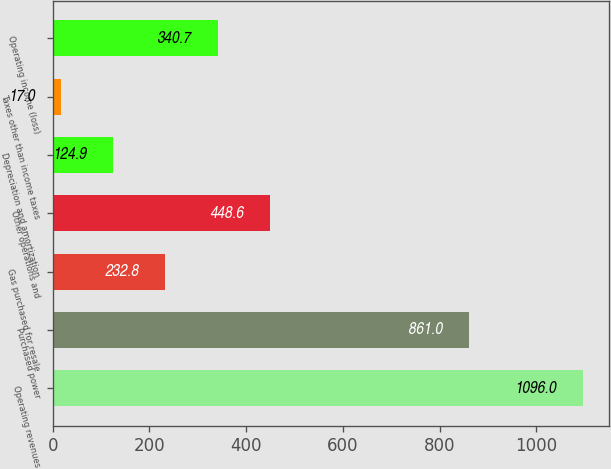<chart> <loc_0><loc_0><loc_500><loc_500><bar_chart><fcel>Operating revenues<fcel>Purchased power<fcel>Gas purchased for resale<fcel>Other operations and<fcel>Depreciation and amortization<fcel>Taxes other than income taxes<fcel>Operating income (loss)<nl><fcel>1096<fcel>861<fcel>232.8<fcel>448.6<fcel>124.9<fcel>17<fcel>340.7<nl></chart> 